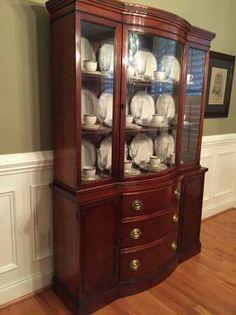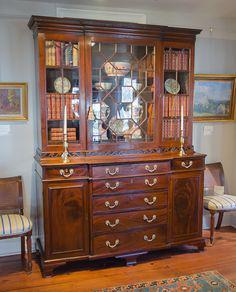The first image is the image on the left, the second image is the image on the right. Analyze the images presented: Is the assertion "There is at least one deep red cabinet with legs." valid? Answer yes or no. No. The first image is the image on the left, the second image is the image on the right. Evaluate the accuracy of this statement regarding the images: "there are two cabinets on the bottom of the hutch on the right". Is it true? Answer yes or no. Yes. 